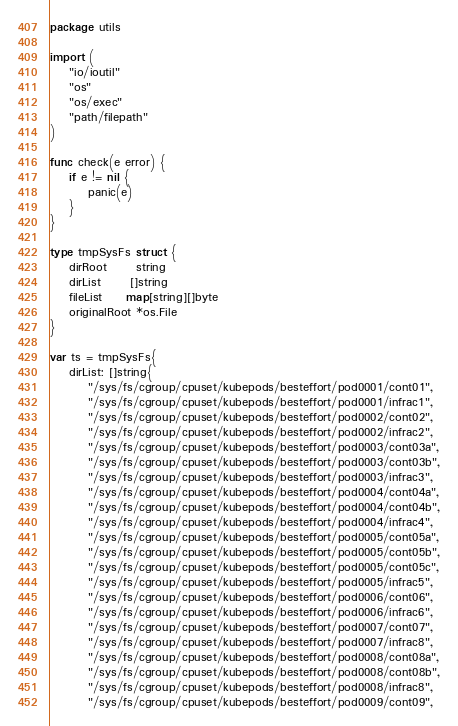<code> <loc_0><loc_0><loc_500><loc_500><_Go_>package utils

import (
	"io/ioutil"
	"os"
	"os/exec"
	"path/filepath"
)

func check(e error) {
	if e != nil {
		panic(e)
	}
}

type tmpSysFs struct {
	dirRoot      string
	dirList      []string
	fileList     map[string][]byte
	originalRoot *os.File
}

var ts = tmpSysFs{
	dirList: []string{
		"/sys/fs/cgroup/cpuset/kubepods/besteffort/pod0001/cont01",
		"/sys/fs/cgroup/cpuset/kubepods/besteffort/pod0001/infrac1",
		"/sys/fs/cgroup/cpuset/kubepods/besteffort/pod0002/cont02",
		"/sys/fs/cgroup/cpuset/kubepods/besteffort/pod0002/infrac2",
		"/sys/fs/cgroup/cpuset/kubepods/besteffort/pod0003/cont03a",
		"/sys/fs/cgroup/cpuset/kubepods/besteffort/pod0003/cont03b",
		"/sys/fs/cgroup/cpuset/kubepods/besteffort/pod0003/infrac3",
		"/sys/fs/cgroup/cpuset/kubepods/besteffort/pod0004/cont04a",
		"/sys/fs/cgroup/cpuset/kubepods/besteffort/pod0004/cont04b",
		"/sys/fs/cgroup/cpuset/kubepods/besteffort/pod0004/infrac4",
		"/sys/fs/cgroup/cpuset/kubepods/besteffort/pod0005/cont05a",
		"/sys/fs/cgroup/cpuset/kubepods/besteffort/pod0005/cont05b",
		"/sys/fs/cgroup/cpuset/kubepods/besteffort/pod0005/cont05c",
		"/sys/fs/cgroup/cpuset/kubepods/besteffort/pod0005/infrac5",
		"/sys/fs/cgroup/cpuset/kubepods/besteffort/pod0006/cont06",
		"/sys/fs/cgroup/cpuset/kubepods/besteffort/pod0006/infrac6",
		"/sys/fs/cgroup/cpuset/kubepods/besteffort/pod0007/cont07",
		"/sys/fs/cgroup/cpuset/kubepods/besteffort/pod0007/infrac8",
		"/sys/fs/cgroup/cpuset/kubepods/besteffort/pod0008/cont08a",
		"/sys/fs/cgroup/cpuset/kubepods/besteffort/pod0008/cont08b",
		"/sys/fs/cgroup/cpuset/kubepods/besteffort/pod0008/infrac8",
		"/sys/fs/cgroup/cpuset/kubepods/besteffort/pod0009/cont09",</code> 